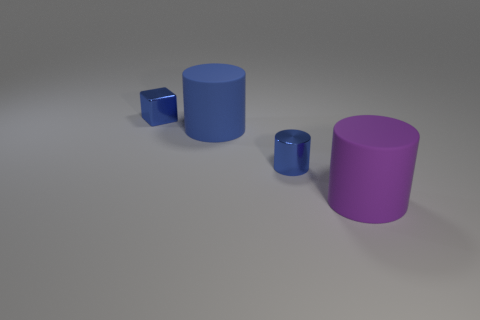How many matte cylinders have the same color as the cube?
Ensure brevity in your answer.  1. Are there any red things of the same shape as the big blue object?
Offer a terse response. No. What is the color of the matte thing that is left of the small blue thing in front of the matte thing behind the purple cylinder?
Give a very brief answer. Blue. How many matte objects are blue things or big cyan cylinders?
Make the answer very short. 1. Is the number of tiny blue metal objects on the right side of the large blue matte cylinder greater than the number of purple objects to the left of the metal block?
Keep it short and to the point. Yes. What number of other things are there of the same size as the shiny block?
Make the answer very short. 1. What is the size of the object behind the big matte cylinder that is behind the small cylinder?
Give a very brief answer. Small. How many tiny things are either brown shiny cylinders or blue cylinders?
Your response must be concise. 1. How big is the blue cylinder behind the tiny blue object on the right side of the small thing left of the blue rubber object?
Give a very brief answer. Large. Is there anything else that is the same color as the tiny cylinder?
Your answer should be very brief. Yes. 